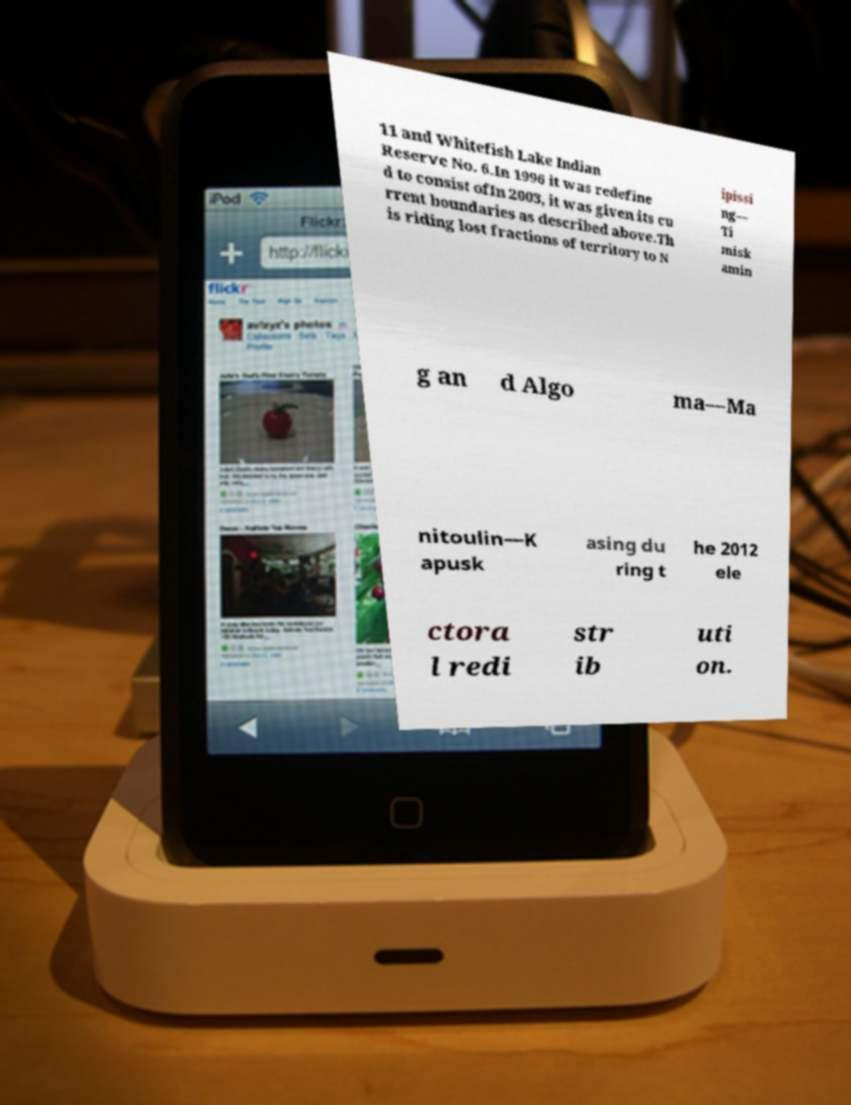Please read and relay the text visible in this image. What does it say? 11 and Whitefish Lake Indian Reserve No. 6.In 1996 it was redefine d to consist ofIn 2003, it was given its cu rrent boundaries as described above.Th is riding lost fractions of territory to N ipissi ng— Ti misk amin g an d Algo ma—Ma nitoulin—K apusk asing du ring t he 2012 ele ctora l redi str ib uti on. 